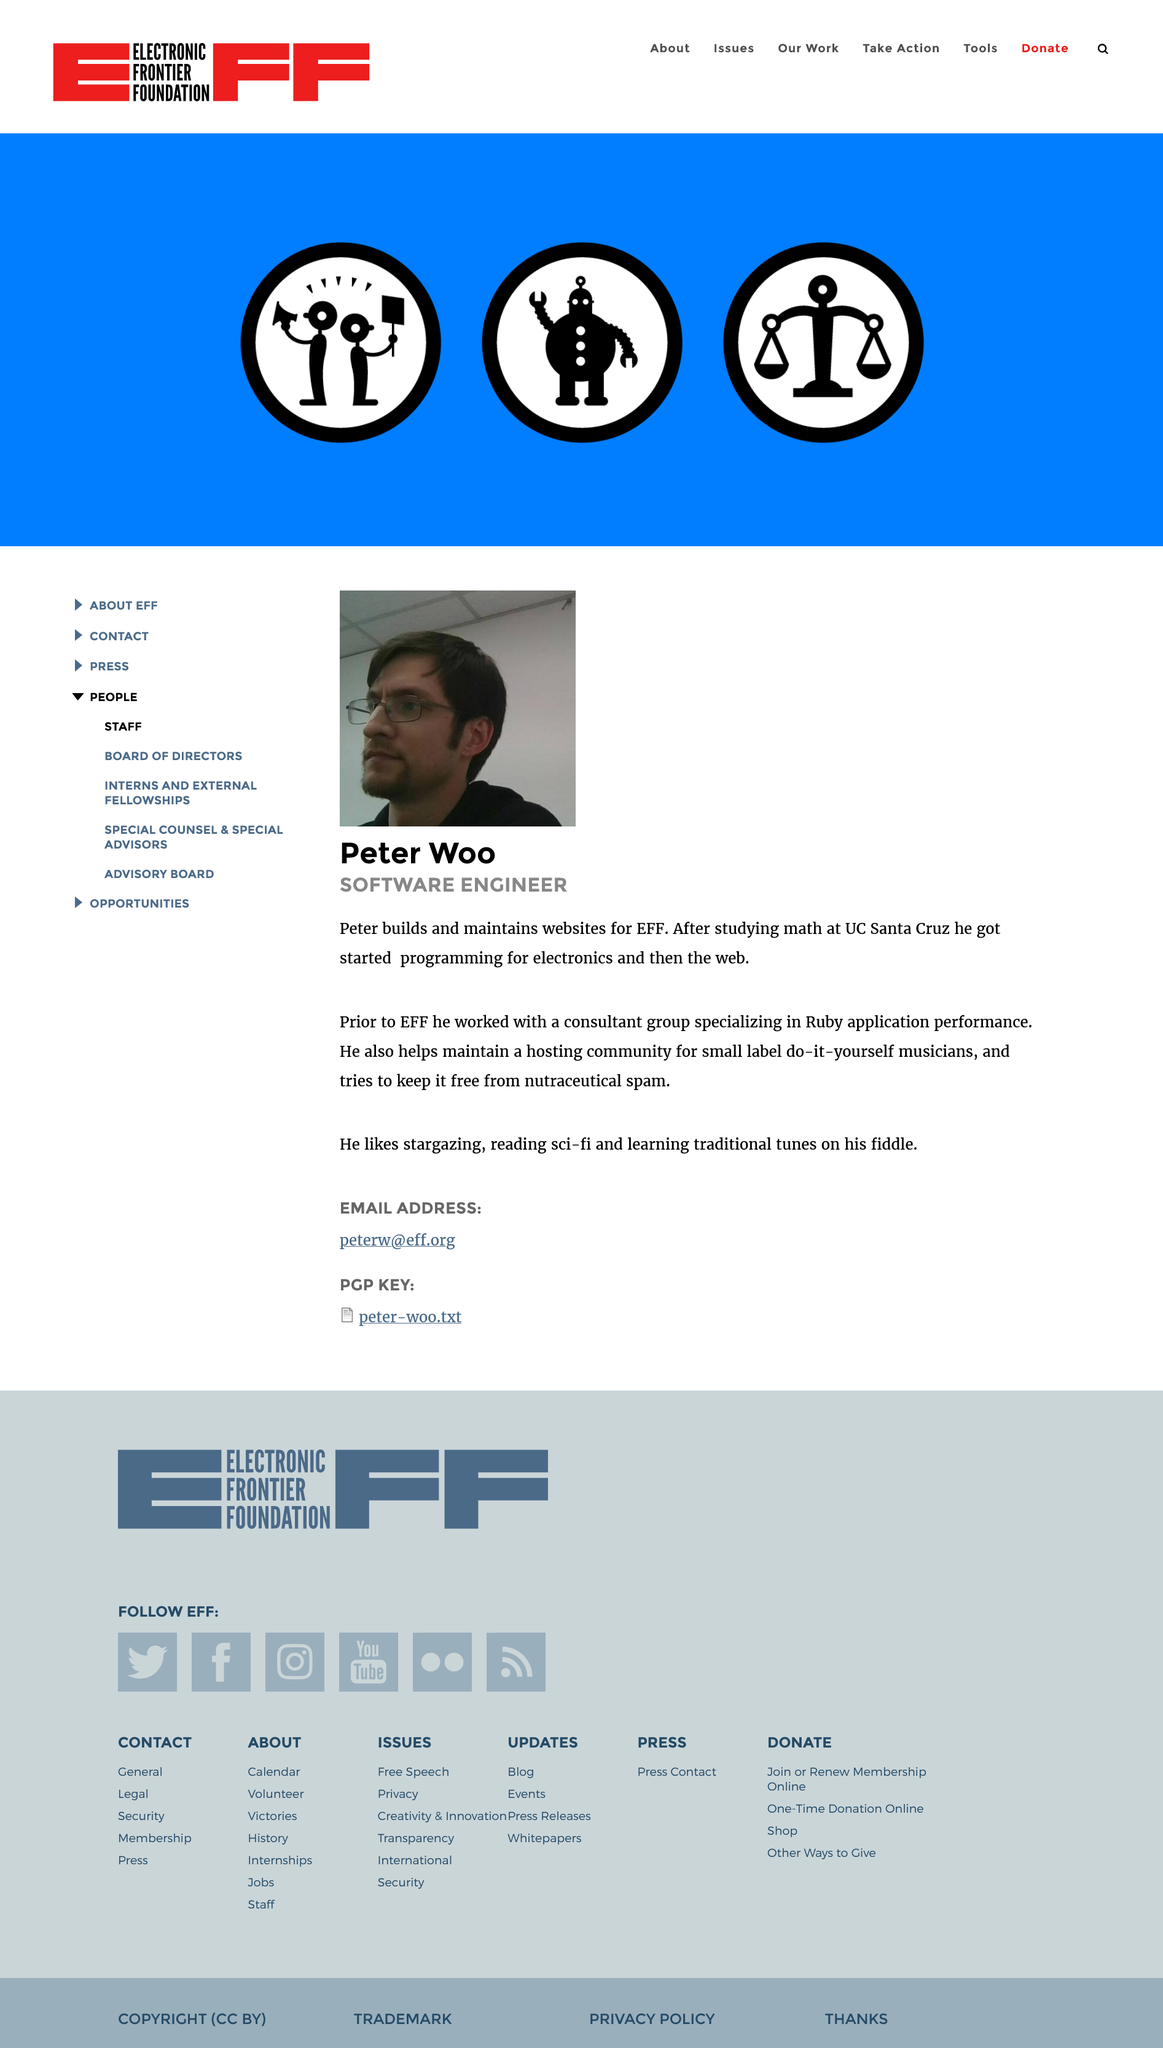Specify some key components in this picture. This page is a biography. Peter Woo is a software engineer and he builds and maintains websites for the Electronic Frontier Foundation (EFF). Peter Woo's hobbies include stargazing, reading science fiction, and learning traditional tunes on his fiddle. 